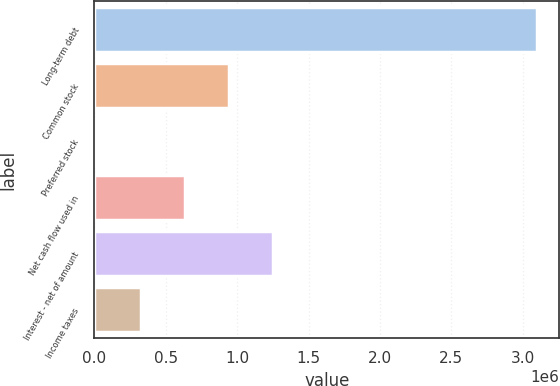<chart> <loc_0><loc_0><loc_500><loc_500><bar_chart><fcel>Long-term debt<fcel>Common stock<fcel>Preferred stock<fcel>Net cash flow used in<fcel>Interest - net of amount<fcel>Income taxes<nl><fcel>3.10007e+06<fcel>943678<fcel>19511<fcel>635623<fcel>1.25173e+06<fcel>327567<nl></chart> 